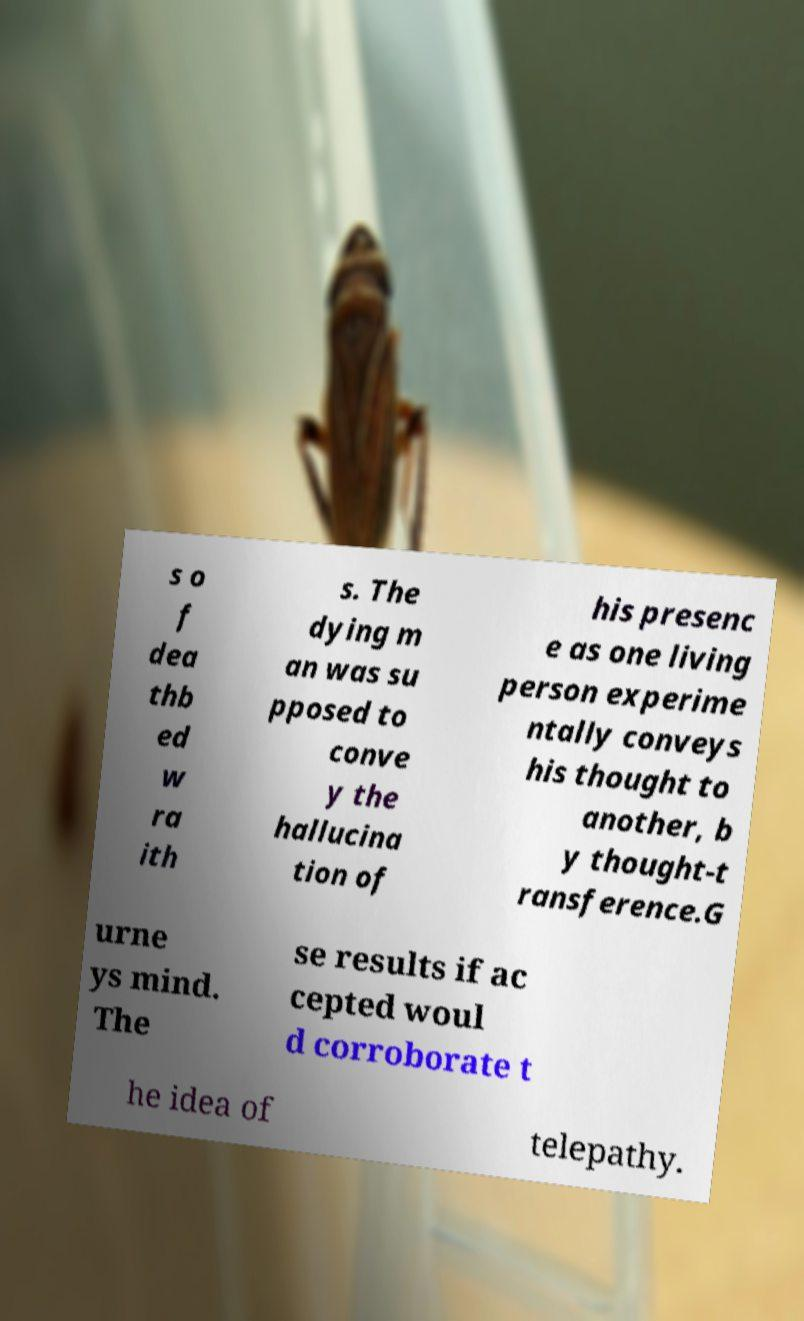Could you extract and type out the text from this image? s o f dea thb ed w ra ith s. The dying m an was su pposed to conve y the hallucina tion of his presenc e as one living person experime ntally conveys his thought to another, b y thought-t ransference.G urne ys mind. The se results if ac cepted woul d corroborate t he idea of telepathy. 